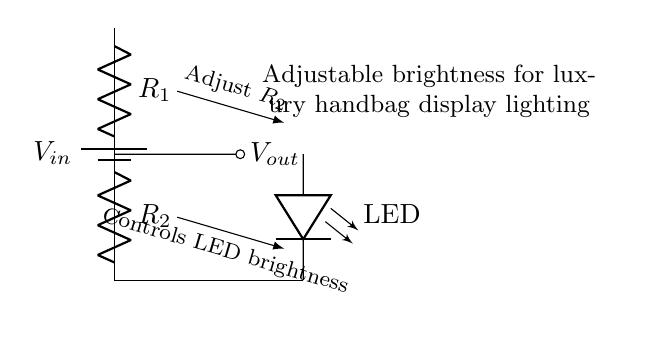What is the type of circuit shown? The circuit shown is a voltage divider, which is a specific configuration of resistors used to divide the input voltage into a lower output voltage.
Answer: voltage divider What component is used to control LED brightness? The component used to control LED brightness is the resistor labeled R2, which adjusts the output voltage across the LED when modified.
Answer: R2 What voltage is labeled as Vout? Vout refers to the output voltage across the LED in the circuit, which is determined by the values of R1 and R2 in the voltage divider arrangement.
Answer: Vout How many resistors are present in this circuit? There are two resistors in the circuit, labeled R1 and R2. This is typical for a voltage divider which requires two resistive elements to achieve the voltage division.
Answer: two What happens to LED brightness if R2 is increased? If R2 is increased, the output voltage Vout decreases, which in turn reduces the current through the LED, leading to dimmer brightness.
Answer: LED dims What is the input voltage labeled as in the circuit? The input voltage is labeled as Vin, which represents the voltage supplied to the circuit from the battery connected at the top.
Answer: Vin What is the primary function of this circuit in the context of the handbags display? The primary function is to provide adjustable brightness control for the LED lighting used to accentuate the luxury handbags in the display.
Answer: adjustable brightness 